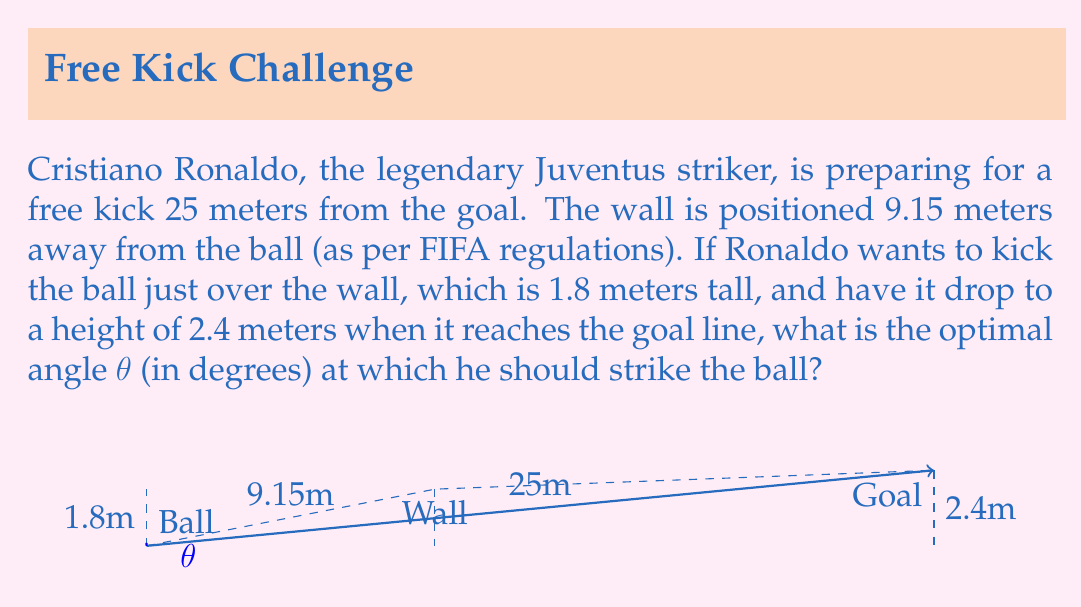Teach me how to tackle this problem. Let's approach this step-by-step using trigonometry:

1) First, we need to find the angle θ that the ball's trajectory makes with the horizontal.

2) We can use the tangent function to find this angle. The tangent of an angle is the ratio of the opposite side to the adjacent side in a right triangle.

3) In our case, the opposite side is the difference in height between the goal and the ball's starting position (2.4m - 0m = 2.4m), and the adjacent side is the distance to the goal (25m).

4) Therefore:

   $$\tan(\theta) = \frac{2.4}{25}$$

5) To find θ, we need to take the inverse tangent (arctan or tan^(-1)) of both sides:

   $$\theta = \tan^{-1}(\frac{2.4}{25})$$

6) Using a calculator or computer, we can evaluate this:

   $$\theta \approx 5.4936°$$

7) However, we need to check if this angle will clear the wall. At the wall's position (9.15m from the ball), the height of the ball should be greater than 1.8m.

8) We can check this using the equation of the line:

   $$y = (\tan(\theta))x$$

   At x = 9.15m, y = tan(5.4936°) * 9.15 ≈ 0.8789m

9) This is less than 1.8m, so Ronaldo needs to kick at a steeper angle.

10) Let's set up an equation where the ball just clears the wall:

    $$\tan(\theta) * 9.15 = 1.8$$

11) Solving for θ:

    $$\theta = \tan^{-1}(\frac{1.8}{9.15}) \approx 11.1371°$$

This angle will clear the wall and is the minimum angle needed to do so, making it the optimal angle for the free kick.
Answer: $11.14°$ 